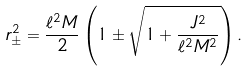<formula> <loc_0><loc_0><loc_500><loc_500>r _ { \pm } ^ { 2 } = \frac { \ell ^ { 2 } M } { 2 } \left ( 1 \pm \sqrt { 1 + \frac { J ^ { 2 } } { \ell ^ { 2 } M ^ { 2 } } } \right ) .</formula> 